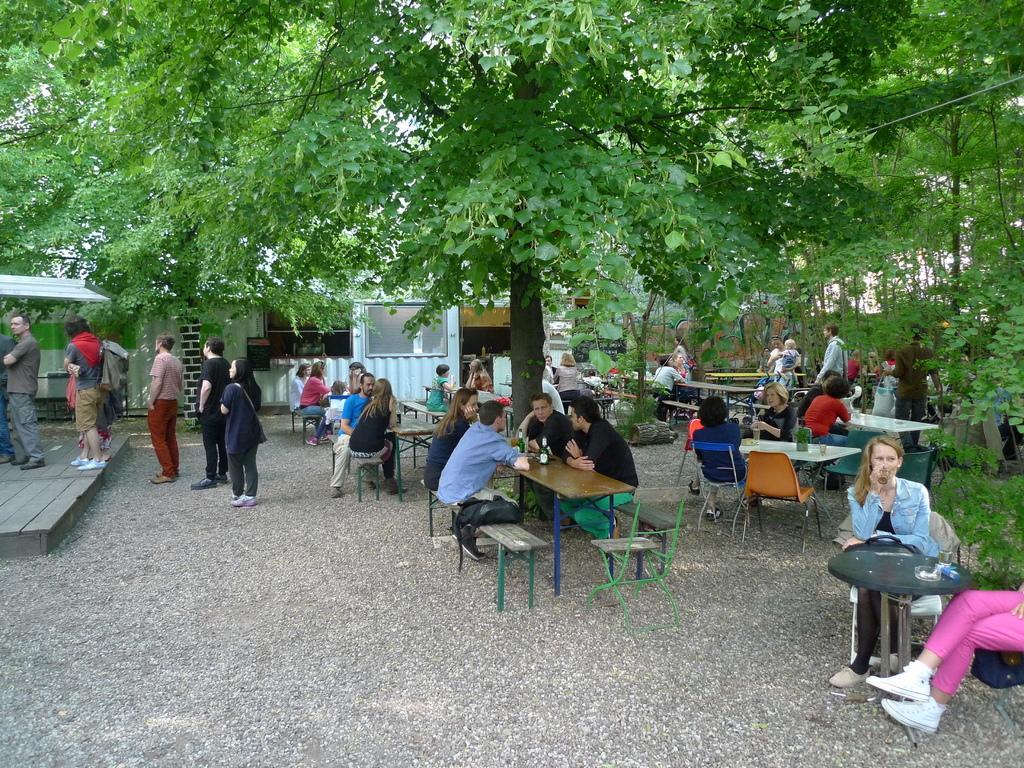Describe this image in one or two sentences. This picture describes about group of people, few people are seated and few are standing, in front of them we can see few bottles on the table, in the background we can see few trees and houses. 